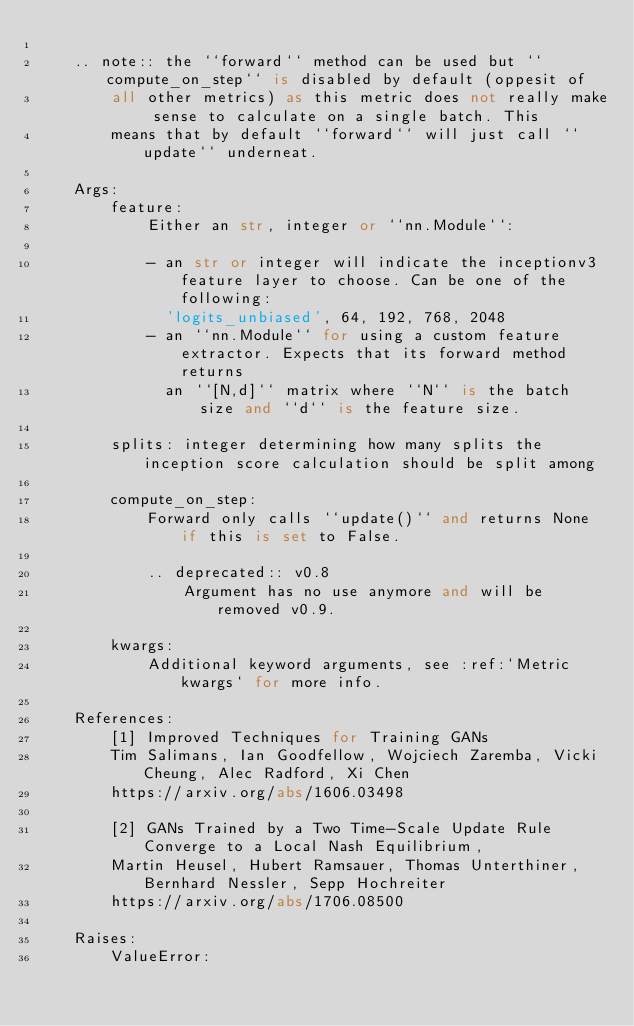Convert code to text. <code><loc_0><loc_0><loc_500><loc_500><_Python_>
    .. note:: the ``forward`` method can be used but ``compute_on_step`` is disabled by default (oppesit of
        all other metrics) as this metric does not really make sense to calculate on a single batch. This
        means that by default ``forward`` will just call ``update`` underneat.

    Args:
        feature:
            Either an str, integer or ``nn.Module``:

            - an str or integer will indicate the inceptionv3 feature layer to choose. Can be one of the following:
              'logits_unbiased', 64, 192, 768, 2048
            - an ``nn.Module`` for using a custom feature extractor. Expects that its forward method returns
              an ``[N,d]`` matrix where ``N`` is the batch size and ``d`` is the feature size.

        splits: integer determining how many splits the inception score calculation should be split among

        compute_on_step:
            Forward only calls ``update()`` and returns None if this is set to False.

            .. deprecated:: v0.8
                Argument has no use anymore and will be removed v0.9.

        kwargs:
            Additional keyword arguments, see :ref:`Metric kwargs` for more info.

    References:
        [1] Improved Techniques for Training GANs
        Tim Salimans, Ian Goodfellow, Wojciech Zaremba, Vicki Cheung, Alec Radford, Xi Chen
        https://arxiv.org/abs/1606.03498

        [2] GANs Trained by a Two Time-Scale Update Rule Converge to a Local Nash Equilibrium,
        Martin Heusel, Hubert Ramsauer, Thomas Unterthiner, Bernhard Nessler, Sepp Hochreiter
        https://arxiv.org/abs/1706.08500

    Raises:
        ValueError:</code> 